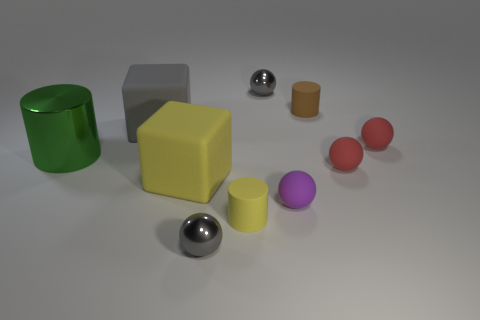There is a big rubber cube in front of the large gray rubber object that is behind the large yellow rubber block; how many purple objects are behind it?
Your answer should be compact. 0. Is there any other thing of the same color as the metallic cylinder?
Provide a succinct answer. No. Does the gray metal ball that is behind the green cylinder have the same size as the gray cube?
Ensure brevity in your answer.  No. How many purple matte spheres are on the left side of the gray thing left of the big yellow cube?
Your response must be concise. 0. There is a small metal thing on the right side of the yellow object that is right of the big yellow rubber object; are there any tiny objects in front of it?
Give a very brief answer. Yes. There is another big object that is the same shape as the gray matte thing; what is its material?
Offer a terse response. Rubber. Are the green cylinder and the large cube that is to the left of the yellow block made of the same material?
Offer a very short reply. No. There is a yellow rubber thing that is on the right side of the thing in front of the yellow rubber cylinder; what is its shape?
Provide a short and direct response. Cylinder. What number of large objects are purple metal blocks or red matte spheres?
Keep it short and to the point. 0. What number of other tiny matte things have the same shape as the tiny brown matte thing?
Ensure brevity in your answer.  1. 